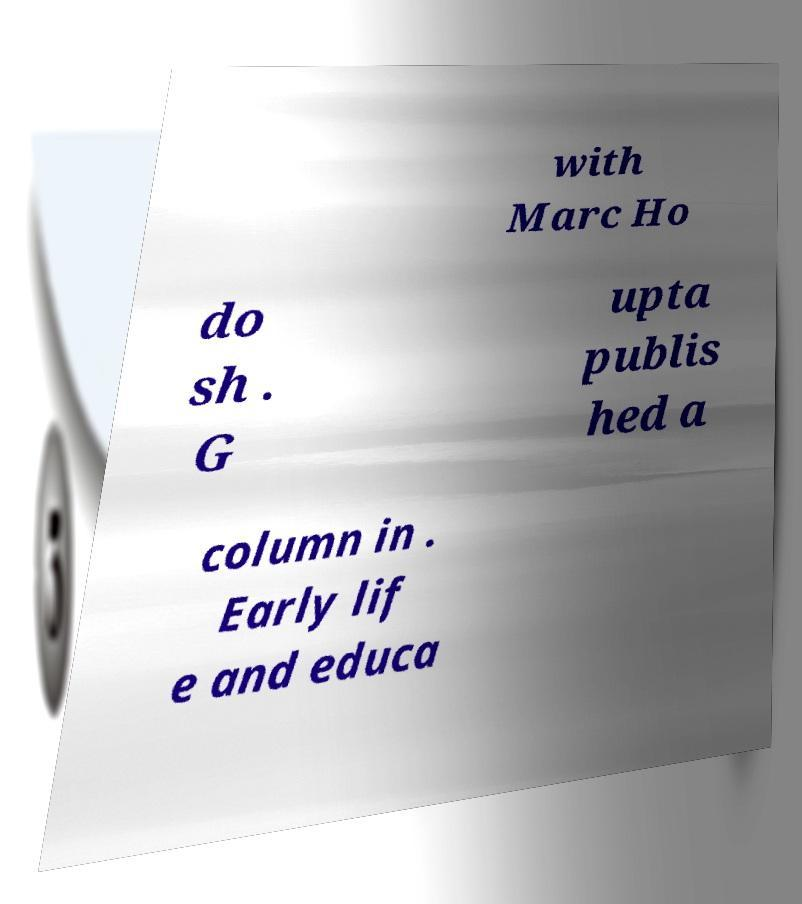Could you assist in decoding the text presented in this image and type it out clearly? with Marc Ho do sh . G upta publis hed a column in . Early lif e and educa 